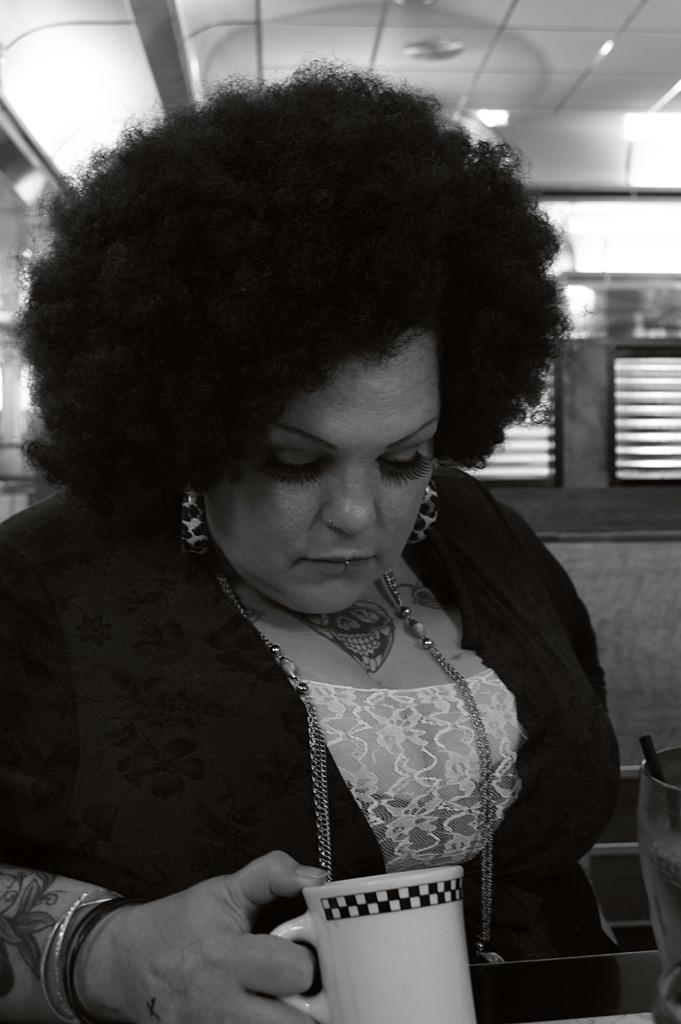What is the color scheme of the image? The image is black and white. Who is present in the image? There is a woman in the image. What is the woman holding in the image? The woman is holding a cup. What can be seen in the background of the image? There is a wall in the background of the image, and there are windows on the wall. What type of circle can be seen on the woman's shirt in the image? There is no circle present on the woman's shirt in the image. What paste is the woman using to stick the paper on the wall in the image? There is no paper or paste present in the image; the woman is holding a cup. 